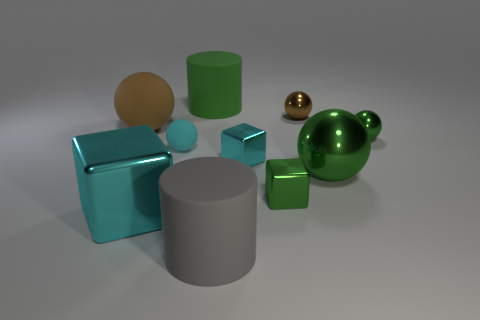Does this arrangement of objects serve any practical purpose, or is it purely artistic? This arrangement of objects likely doesn't serve a practical purpose but instead seems intended for artistic exploration or possibly for a demonstration in a context such as computer graphics rendering. The various shapes and colors, alongside the interplay of light and shadow, contribute to an aesthetic study, exhibiting how different elements interact with one another within a space. 